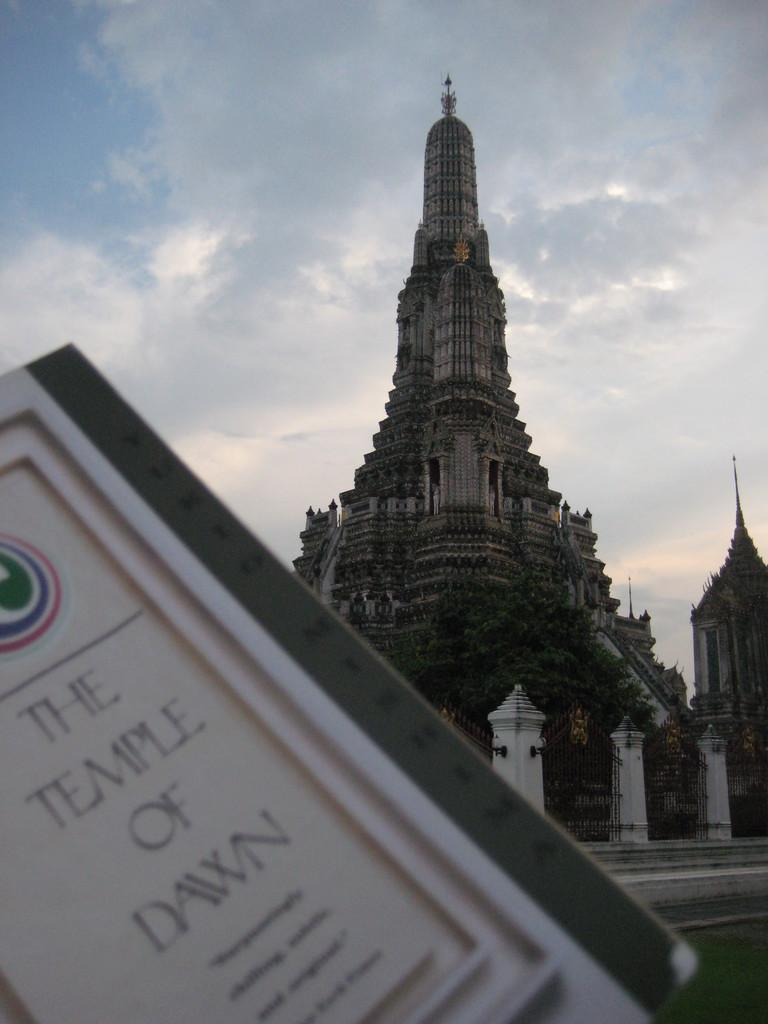What type of structure is in the image? There is a temple in the image. What is in front of the temple? There is a beam in front of the temple. What other natural element is present in the image? There is a tree in the image. What can be seen at the top of the image? The sky is visible at the top of the image. What object with text is present in the image? There is a board in the image with text on it. How many ladybugs are crawling on the temple in the image? There are no ladybugs present in the image. What type of mountain is visible in the background of the image? There is no mountain visible in the image; it only features a temple, beam, tree, sky, and board with text. 